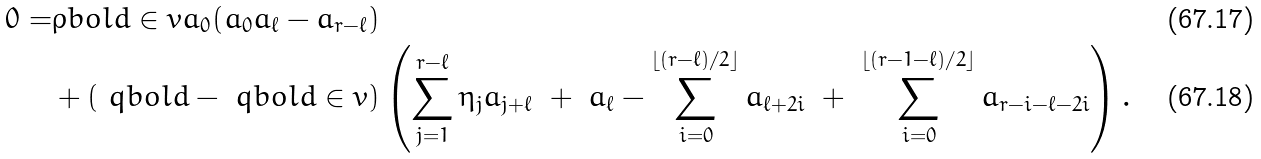Convert formula to latex. <formula><loc_0><loc_0><loc_500><loc_500>0 = & \rho b o l d \in v a _ { 0 } ( a _ { 0 } a _ { \ell } - a _ { r - \ell } ) \\ & + ( \ q b o l d - \ q b o l d \in v ) \left ( \sum _ { j = 1 } ^ { r - \ell } \eta _ { j } a _ { j + \ell } \ + \ a _ { \ell } - \sum _ { i = 0 } ^ { \lfloor ( r - \ell ) / { 2 } \rfloor } a _ { \ell + 2 i } \ + \ \sum _ { i = 0 } ^ { \lfloor ( r - 1 - \ell ) / { 2 } \rfloor } a _ { r - i - \ell - 2 i } \right ) .</formula> 